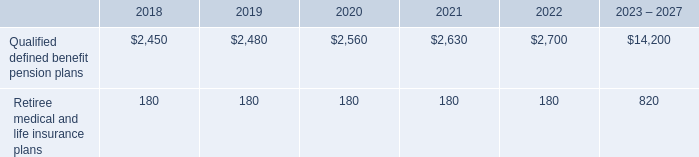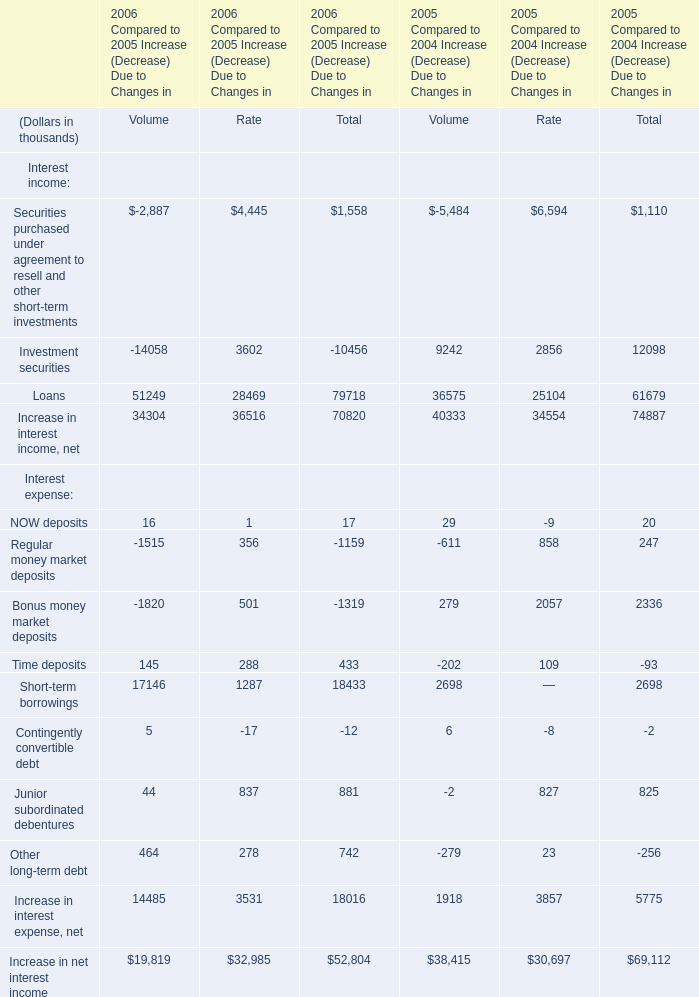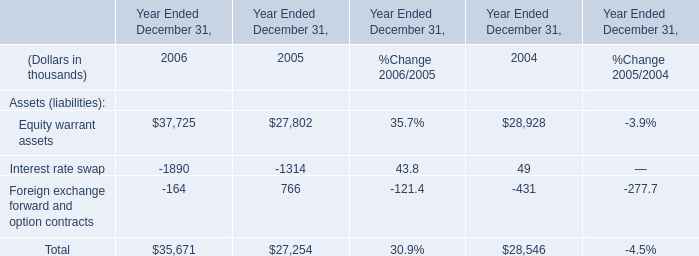What is the average amount of Equity warrant assets of Year Ended December 31, 2005, and Qualified defined benefit pension plans of 2021 ? 
Computations: ((27802.0 + 2630.0) / 2)
Answer: 15216.0. 